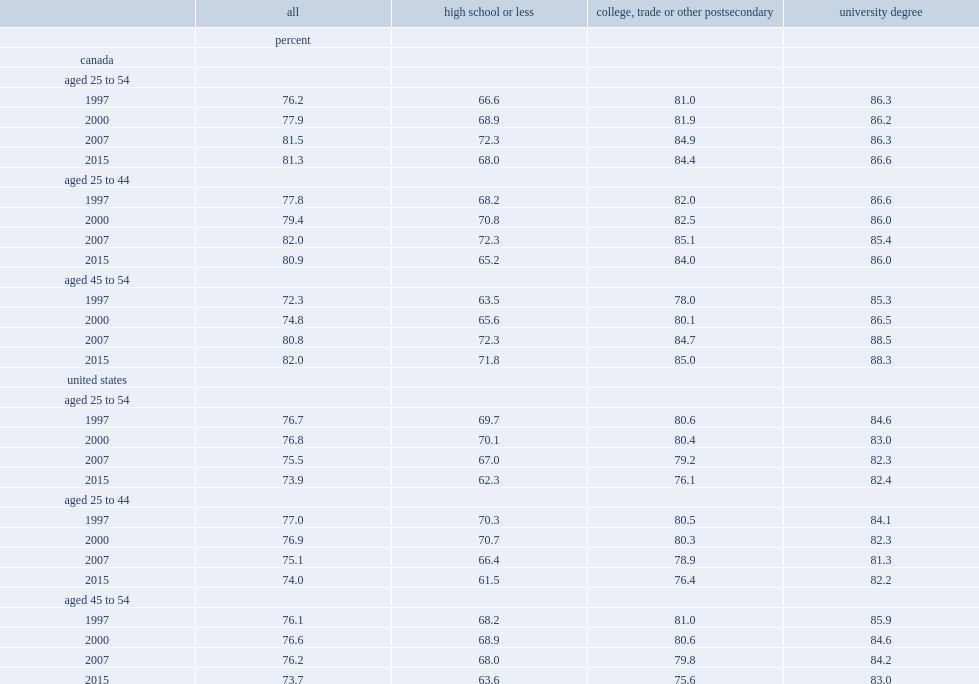Among canadian women aged 45 to 54 with a high school diploma or less, how many percentage points of the rate has increased from 1997 to 2015? 8.3. Among canadian women aged 45 to 54 with a college-level education, how many percent of the rate has increased from 1997 to 2015? 7. In united states, for women aged 45 to 54 with at most a high school diploma, what are the lfpr in 1997 and in 2015 respectively? 68.2 63.6. 